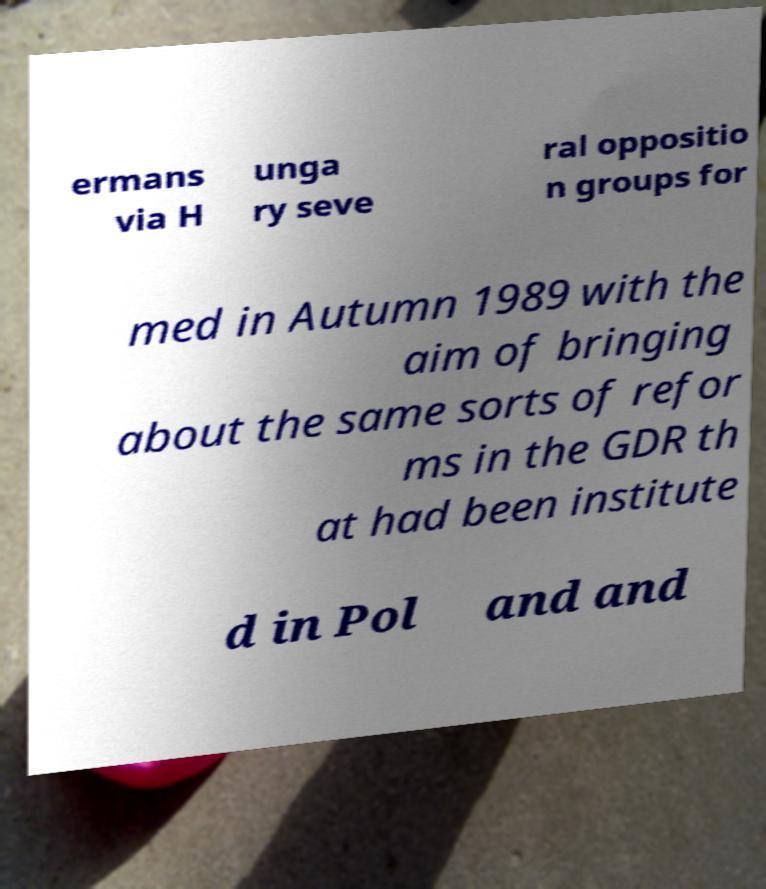I need the written content from this picture converted into text. Can you do that? ermans via H unga ry seve ral oppositio n groups for med in Autumn 1989 with the aim of bringing about the same sorts of refor ms in the GDR th at had been institute d in Pol and and 